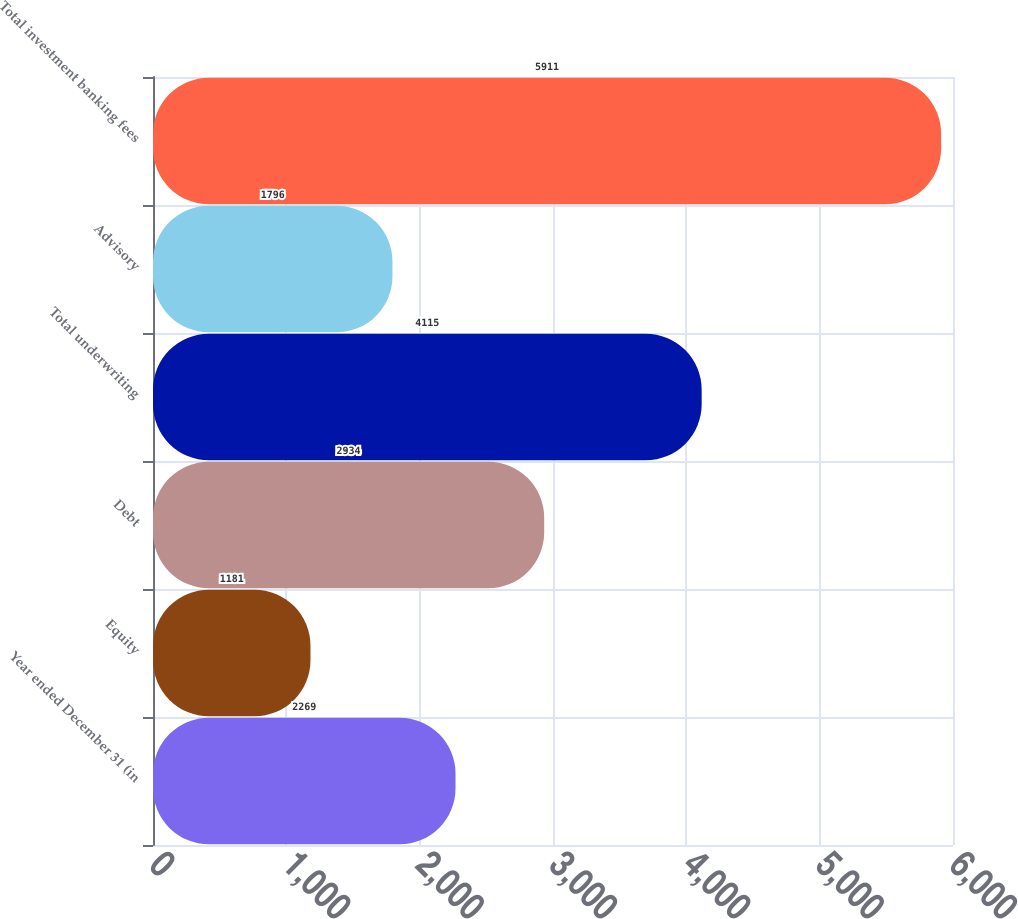<chart> <loc_0><loc_0><loc_500><loc_500><bar_chart><fcel>Year ended December 31 (in<fcel>Equity<fcel>Debt<fcel>Total underwriting<fcel>Advisory<fcel>Total investment banking fees<nl><fcel>2269<fcel>1181<fcel>2934<fcel>4115<fcel>1796<fcel>5911<nl></chart> 